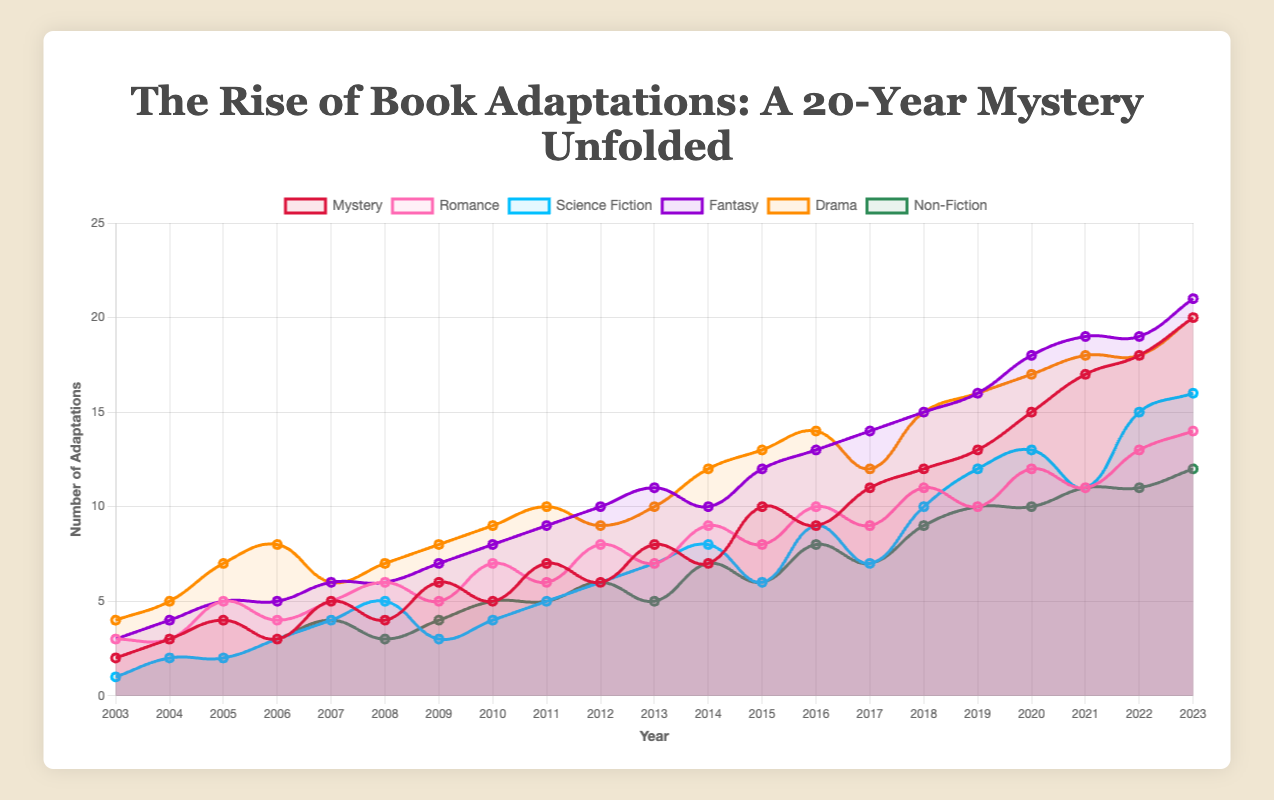Which genre saw the highest number of book adaptations in 2023? To find the highest number of book adaptations in 2023, look at the endpoints of each line on the plot for the year 2023. Fantasy has the highest point at 21 adaptations.
Answer: Fantasy How did the number of mystery adaptations change from 2003 to 2023? Refer to the starting and ending points of the Mystery line on the plot. In 2003, Mystery had 2 adaptations, and in 2023, it had 20. The change is 20 - 2 = 18.
Answer: Increased by 18 Which genres had a dip in adaptations around the year 2015? Look for a downward trend around 2015. Mystery, Science Fiction, and Non-Fiction showed some dips around 2015.
Answer: Mystery, Science Fiction, Non-Fiction What is the sum of book adaptations in all genres for the year 2010? Add the values from each genre for the year 2010. Mystery: 5, Romance: 7, Science Fiction: 4, Fantasy: 8, Drama: 9, Non-Fiction: 5. The sum is 5 + 7 + 4 + 8 + 9 + 5 = 38.
Answer: 38 Which genre has the most consistent trend over the past 20 years? Identify the line that shows a relatively steady increase without large fluctuations. Drama maintains a more consistent upward trend compared to the others.
Answer: Drama What was the average number of Romance adaptations from 2003 to 2023? Sum the number of Romance adaptations from 2003 to 2023 and divide by the number of years (21). The sum is 175, and the average is 175 / 21 ≈ 8.33.
Answer: 8.33 How did the adaptations in Science Fiction change post-2010 compared to pre-2010? Compare the number of adaptations from 2003 to 2010 (pre-2010) and from 2011 to 2023 (post-2010). Pre-2010 sum is 24, post-2010 sum is 109. The change is 109 - 24 = 85.
Answer: Increased by 85 Which genre surpassed Mystery in the number of adaptations the earliest, and in what year? Look at the plot to see when another genre's line first goes above Mystery's line. Fantasy surpassed Mystery in 2011.
Answer: Fantasy, 2011 